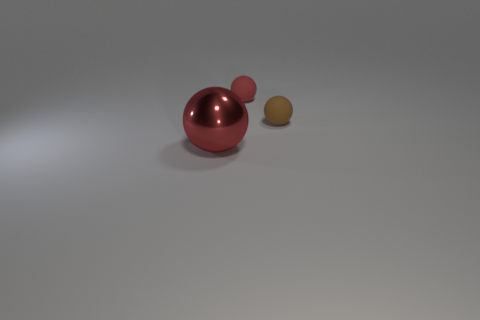Subtract all blue balls. Subtract all yellow cubes. How many balls are left? 3 Add 3 brown matte spheres. How many objects exist? 6 Add 2 tiny brown rubber balls. How many tiny brown rubber balls exist? 3 Subtract 0 red cubes. How many objects are left? 3 Subtract all tiny yellow things. Subtract all tiny rubber things. How many objects are left? 1 Add 2 tiny red rubber objects. How many tiny red rubber objects are left? 3 